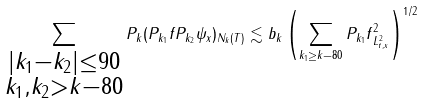<formula> <loc_0><loc_0><loc_500><loc_500>\sum _ { \substack { | k _ { 1 } - k _ { 2 } | \leq 9 0 \\ k _ { 1 } , k _ { 2 } > k - 8 0 } } \| P _ { k } ( P _ { k _ { 1 } } f P _ { k _ { 2 } } \psi _ { x } ) \| _ { N _ { k } ( T ) } \lesssim b _ { k } \left ( \sum _ { k _ { 1 } \geq k - 8 0 } \| P _ { k _ { 1 } } f \| _ { L _ { t , x } ^ { 2 } } ^ { 2 } \right ) ^ { 1 / 2 }</formula> 